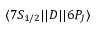<formula> <loc_0><loc_0><loc_500><loc_500>{ \langle 7 S _ { 1 / 2 } | | } D { | | 6 P _ { J } \rangle }</formula> 